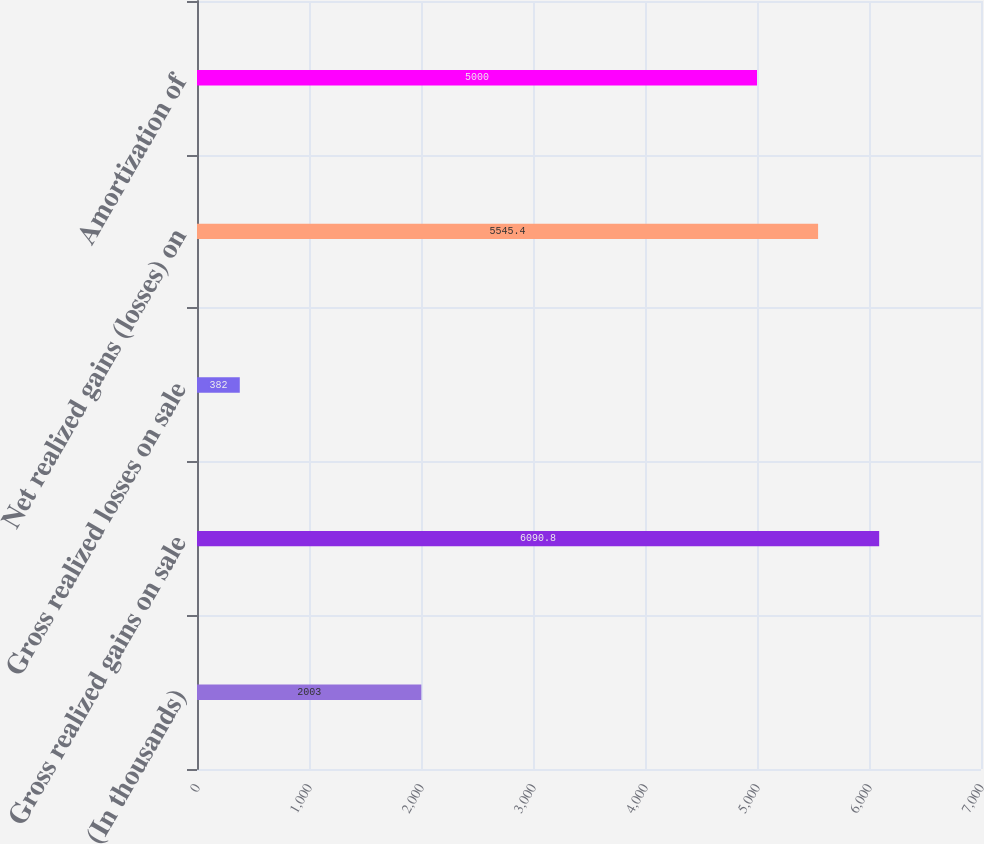Convert chart. <chart><loc_0><loc_0><loc_500><loc_500><bar_chart><fcel>(In thousands)<fcel>Gross realized gains on sale<fcel>Gross realized losses on sale<fcel>Net realized gains (losses) on<fcel>Amortization of<nl><fcel>2003<fcel>6090.8<fcel>382<fcel>5545.4<fcel>5000<nl></chart> 